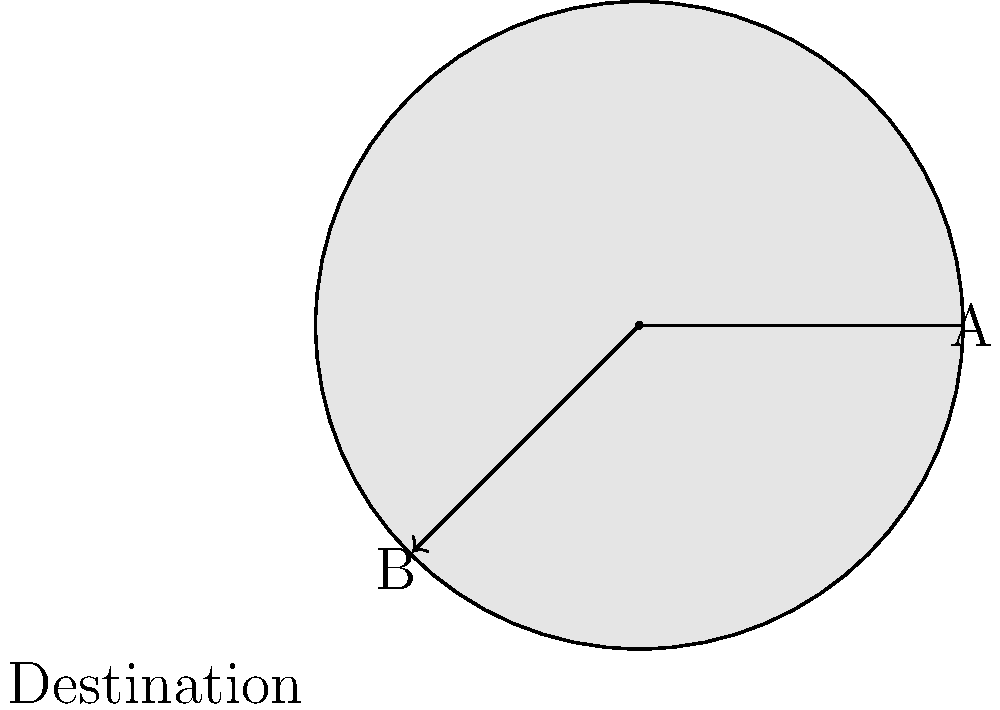As a flight enthusiast examining a weather radar image for a planned route from point A to point B, what is the most appropriate action to take based on the depicted weather conditions? To answer this question, let's analyze the weather radar image step-by-step:

1. Radar Interpretation:
   - The circular image represents different intensities of precipitation.
   - Lighter colors (outer rings) indicate light precipitation.
   - Darker colors (inner rings) indicate heavier precipitation.

2. Flight Path Analysis:
   - The planned route goes from point A to point B.
   - The path intersects with all levels of precipitation, including the darkest center.

3. Weather Hazards:
   - The darkest center likely represents very heavy precipitation, possibly a thunderstorm.
   - Flying through such conditions can be extremely dangerous due to:
     a) Severe turbulence
     b) Potential for hail
     c) Risk of lightning strikes
     d) Reduced visibility

4. Flight Safety Considerations:
   - As an impressed flight enthusiast, you should prioritize safety above all.
   - Flying directly through a severe weather system is never recommended.

5. Alternative Options:
   - Delay the flight until the weather system passes.
   - Reroute the flight path to avoid the severe weather, possibly flying around the outer edges of the system.

6. Best Practice:
   - In aviation, it's always better to err on the side of caution.
   - The safest option is to avoid the weather system entirely.

Given these factors, the most appropriate action would be to either delay the flight or significantly alter the route to avoid the severe weather entirely.
Answer: Delay flight or reroute to avoid severe weather 